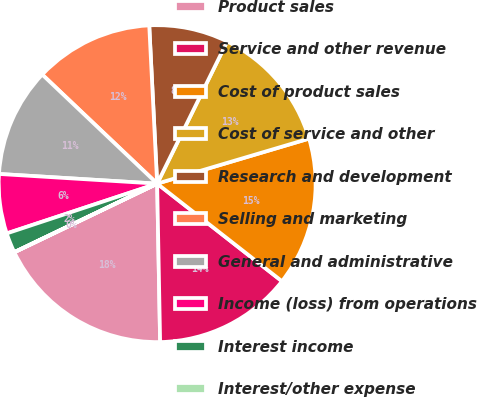Convert chart to OTSL. <chart><loc_0><loc_0><loc_500><loc_500><pie_chart><fcel>Product sales<fcel>Service and other revenue<fcel>Cost of product sales<fcel>Cost of service and other<fcel>Research and development<fcel>Selling and marketing<fcel>General and administrative<fcel>Income (loss) from operations<fcel>Interest income<fcel>Interest/other expense<nl><fcel>18.17%<fcel>14.14%<fcel>15.15%<fcel>13.13%<fcel>8.08%<fcel>12.12%<fcel>11.11%<fcel>6.06%<fcel>2.03%<fcel>0.01%<nl></chart> 